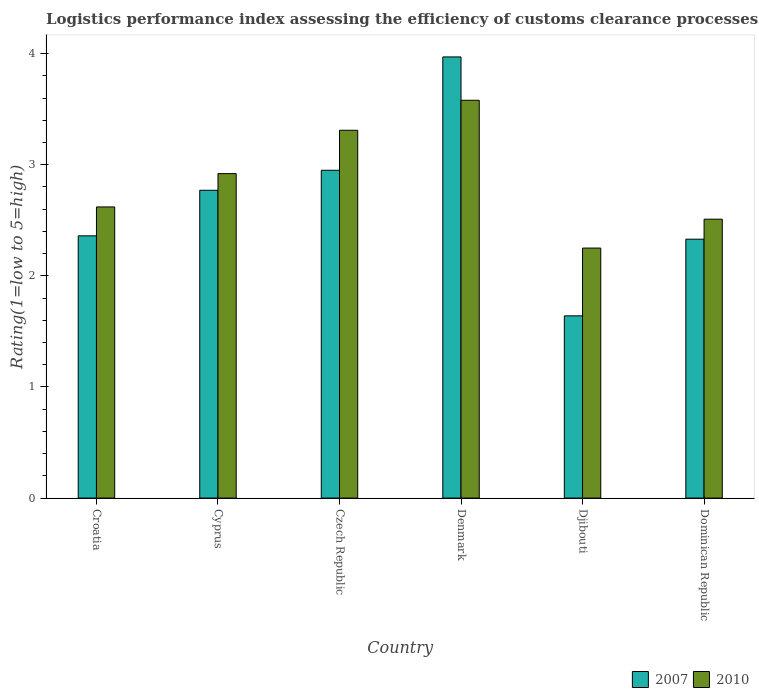Are the number of bars on each tick of the X-axis equal?
Your response must be concise. Yes. How many bars are there on the 6th tick from the left?
Keep it short and to the point. 2. How many bars are there on the 1st tick from the right?
Your answer should be very brief. 2. What is the label of the 1st group of bars from the left?
Offer a very short reply. Croatia. In how many cases, is the number of bars for a given country not equal to the number of legend labels?
Keep it short and to the point. 0. What is the Logistic performance index in 2007 in Cyprus?
Your answer should be very brief. 2.77. Across all countries, what is the maximum Logistic performance index in 2010?
Provide a short and direct response. 3.58. Across all countries, what is the minimum Logistic performance index in 2010?
Provide a succinct answer. 2.25. In which country was the Logistic performance index in 2007 maximum?
Your response must be concise. Denmark. In which country was the Logistic performance index in 2010 minimum?
Your answer should be compact. Djibouti. What is the total Logistic performance index in 2010 in the graph?
Make the answer very short. 17.19. What is the difference between the Logistic performance index in 2010 in Cyprus and that in Dominican Republic?
Offer a terse response. 0.41. What is the difference between the Logistic performance index in 2010 in Djibouti and the Logistic performance index in 2007 in Cyprus?
Your response must be concise. -0.52. What is the average Logistic performance index in 2010 per country?
Ensure brevity in your answer.  2.86. What is the difference between the Logistic performance index of/in 2010 and Logistic performance index of/in 2007 in Djibouti?
Offer a terse response. 0.61. In how many countries, is the Logistic performance index in 2010 greater than 0.2?
Ensure brevity in your answer.  6. What is the ratio of the Logistic performance index in 2010 in Cyprus to that in Dominican Republic?
Offer a terse response. 1.16. Is the Logistic performance index in 2010 in Cyprus less than that in Czech Republic?
Make the answer very short. Yes. What is the difference between the highest and the second highest Logistic performance index in 2007?
Give a very brief answer. -0.18. What is the difference between the highest and the lowest Logistic performance index in 2010?
Keep it short and to the point. 1.33. In how many countries, is the Logistic performance index in 2007 greater than the average Logistic performance index in 2007 taken over all countries?
Your answer should be very brief. 3. Is the sum of the Logistic performance index in 2007 in Croatia and Czech Republic greater than the maximum Logistic performance index in 2010 across all countries?
Offer a very short reply. Yes. What does the 1st bar from the right in Djibouti represents?
Offer a terse response. 2010. What is the difference between two consecutive major ticks on the Y-axis?
Provide a succinct answer. 1. Are the values on the major ticks of Y-axis written in scientific E-notation?
Your response must be concise. No. Does the graph contain any zero values?
Your answer should be compact. No. Does the graph contain grids?
Provide a succinct answer. No. Where does the legend appear in the graph?
Give a very brief answer. Bottom right. How many legend labels are there?
Your response must be concise. 2. How are the legend labels stacked?
Offer a very short reply. Horizontal. What is the title of the graph?
Make the answer very short. Logistics performance index assessing the efficiency of customs clearance processes. Does "1985" appear as one of the legend labels in the graph?
Provide a short and direct response. No. What is the label or title of the X-axis?
Make the answer very short. Country. What is the label or title of the Y-axis?
Make the answer very short. Rating(1=low to 5=high). What is the Rating(1=low to 5=high) of 2007 in Croatia?
Ensure brevity in your answer.  2.36. What is the Rating(1=low to 5=high) in 2010 in Croatia?
Make the answer very short. 2.62. What is the Rating(1=low to 5=high) in 2007 in Cyprus?
Your answer should be compact. 2.77. What is the Rating(1=low to 5=high) of 2010 in Cyprus?
Offer a very short reply. 2.92. What is the Rating(1=low to 5=high) in 2007 in Czech Republic?
Make the answer very short. 2.95. What is the Rating(1=low to 5=high) in 2010 in Czech Republic?
Offer a very short reply. 3.31. What is the Rating(1=low to 5=high) of 2007 in Denmark?
Provide a succinct answer. 3.97. What is the Rating(1=low to 5=high) in 2010 in Denmark?
Your answer should be very brief. 3.58. What is the Rating(1=low to 5=high) of 2007 in Djibouti?
Give a very brief answer. 1.64. What is the Rating(1=low to 5=high) of 2010 in Djibouti?
Offer a very short reply. 2.25. What is the Rating(1=low to 5=high) of 2007 in Dominican Republic?
Provide a short and direct response. 2.33. What is the Rating(1=low to 5=high) of 2010 in Dominican Republic?
Offer a very short reply. 2.51. Across all countries, what is the maximum Rating(1=low to 5=high) in 2007?
Ensure brevity in your answer.  3.97. Across all countries, what is the maximum Rating(1=low to 5=high) in 2010?
Your answer should be compact. 3.58. Across all countries, what is the minimum Rating(1=low to 5=high) of 2007?
Your answer should be compact. 1.64. Across all countries, what is the minimum Rating(1=low to 5=high) in 2010?
Make the answer very short. 2.25. What is the total Rating(1=low to 5=high) in 2007 in the graph?
Keep it short and to the point. 16.02. What is the total Rating(1=low to 5=high) in 2010 in the graph?
Offer a very short reply. 17.19. What is the difference between the Rating(1=low to 5=high) in 2007 in Croatia and that in Cyprus?
Your answer should be compact. -0.41. What is the difference between the Rating(1=low to 5=high) in 2010 in Croatia and that in Cyprus?
Your answer should be compact. -0.3. What is the difference between the Rating(1=low to 5=high) of 2007 in Croatia and that in Czech Republic?
Give a very brief answer. -0.59. What is the difference between the Rating(1=low to 5=high) of 2010 in Croatia and that in Czech Republic?
Offer a very short reply. -0.69. What is the difference between the Rating(1=low to 5=high) in 2007 in Croatia and that in Denmark?
Keep it short and to the point. -1.61. What is the difference between the Rating(1=low to 5=high) in 2010 in Croatia and that in Denmark?
Provide a short and direct response. -0.96. What is the difference between the Rating(1=low to 5=high) of 2007 in Croatia and that in Djibouti?
Your response must be concise. 0.72. What is the difference between the Rating(1=low to 5=high) of 2010 in Croatia and that in Djibouti?
Ensure brevity in your answer.  0.37. What is the difference between the Rating(1=low to 5=high) in 2010 in Croatia and that in Dominican Republic?
Keep it short and to the point. 0.11. What is the difference between the Rating(1=low to 5=high) of 2007 in Cyprus and that in Czech Republic?
Your answer should be compact. -0.18. What is the difference between the Rating(1=low to 5=high) of 2010 in Cyprus and that in Czech Republic?
Provide a short and direct response. -0.39. What is the difference between the Rating(1=low to 5=high) of 2007 in Cyprus and that in Denmark?
Give a very brief answer. -1.2. What is the difference between the Rating(1=low to 5=high) in 2010 in Cyprus and that in Denmark?
Offer a very short reply. -0.66. What is the difference between the Rating(1=low to 5=high) of 2007 in Cyprus and that in Djibouti?
Offer a very short reply. 1.13. What is the difference between the Rating(1=low to 5=high) in 2010 in Cyprus and that in Djibouti?
Provide a succinct answer. 0.67. What is the difference between the Rating(1=low to 5=high) in 2007 in Cyprus and that in Dominican Republic?
Keep it short and to the point. 0.44. What is the difference between the Rating(1=low to 5=high) of 2010 in Cyprus and that in Dominican Republic?
Provide a short and direct response. 0.41. What is the difference between the Rating(1=low to 5=high) in 2007 in Czech Republic and that in Denmark?
Your response must be concise. -1.02. What is the difference between the Rating(1=low to 5=high) of 2010 in Czech Republic and that in Denmark?
Your answer should be very brief. -0.27. What is the difference between the Rating(1=low to 5=high) of 2007 in Czech Republic and that in Djibouti?
Your response must be concise. 1.31. What is the difference between the Rating(1=low to 5=high) in 2010 in Czech Republic and that in Djibouti?
Offer a very short reply. 1.06. What is the difference between the Rating(1=low to 5=high) of 2007 in Czech Republic and that in Dominican Republic?
Your answer should be compact. 0.62. What is the difference between the Rating(1=low to 5=high) in 2007 in Denmark and that in Djibouti?
Keep it short and to the point. 2.33. What is the difference between the Rating(1=low to 5=high) of 2010 in Denmark and that in Djibouti?
Offer a very short reply. 1.33. What is the difference between the Rating(1=low to 5=high) of 2007 in Denmark and that in Dominican Republic?
Provide a short and direct response. 1.64. What is the difference between the Rating(1=low to 5=high) of 2010 in Denmark and that in Dominican Republic?
Provide a succinct answer. 1.07. What is the difference between the Rating(1=low to 5=high) of 2007 in Djibouti and that in Dominican Republic?
Your response must be concise. -0.69. What is the difference between the Rating(1=low to 5=high) in 2010 in Djibouti and that in Dominican Republic?
Your response must be concise. -0.26. What is the difference between the Rating(1=low to 5=high) in 2007 in Croatia and the Rating(1=low to 5=high) in 2010 in Cyprus?
Ensure brevity in your answer.  -0.56. What is the difference between the Rating(1=low to 5=high) in 2007 in Croatia and the Rating(1=low to 5=high) in 2010 in Czech Republic?
Give a very brief answer. -0.95. What is the difference between the Rating(1=low to 5=high) of 2007 in Croatia and the Rating(1=low to 5=high) of 2010 in Denmark?
Your answer should be compact. -1.22. What is the difference between the Rating(1=low to 5=high) in 2007 in Croatia and the Rating(1=low to 5=high) in 2010 in Djibouti?
Offer a terse response. 0.11. What is the difference between the Rating(1=low to 5=high) in 2007 in Cyprus and the Rating(1=low to 5=high) in 2010 in Czech Republic?
Your response must be concise. -0.54. What is the difference between the Rating(1=low to 5=high) in 2007 in Cyprus and the Rating(1=low to 5=high) in 2010 in Denmark?
Provide a short and direct response. -0.81. What is the difference between the Rating(1=low to 5=high) of 2007 in Cyprus and the Rating(1=low to 5=high) of 2010 in Djibouti?
Provide a short and direct response. 0.52. What is the difference between the Rating(1=low to 5=high) in 2007 in Cyprus and the Rating(1=low to 5=high) in 2010 in Dominican Republic?
Offer a very short reply. 0.26. What is the difference between the Rating(1=low to 5=high) of 2007 in Czech Republic and the Rating(1=low to 5=high) of 2010 in Denmark?
Provide a succinct answer. -0.63. What is the difference between the Rating(1=low to 5=high) in 2007 in Czech Republic and the Rating(1=low to 5=high) in 2010 in Djibouti?
Ensure brevity in your answer.  0.7. What is the difference between the Rating(1=low to 5=high) of 2007 in Czech Republic and the Rating(1=low to 5=high) of 2010 in Dominican Republic?
Give a very brief answer. 0.44. What is the difference between the Rating(1=low to 5=high) of 2007 in Denmark and the Rating(1=low to 5=high) of 2010 in Djibouti?
Give a very brief answer. 1.72. What is the difference between the Rating(1=low to 5=high) of 2007 in Denmark and the Rating(1=low to 5=high) of 2010 in Dominican Republic?
Keep it short and to the point. 1.46. What is the difference between the Rating(1=low to 5=high) of 2007 in Djibouti and the Rating(1=low to 5=high) of 2010 in Dominican Republic?
Ensure brevity in your answer.  -0.87. What is the average Rating(1=low to 5=high) of 2007 per country?
Ensure brevity in your answer.  2.67. What is the average Rating(1=low to 5=high) in 2010 per country?
Offer a very short reply. 2.87. What is the difference between the Rating(1=low to 5=high) of 2007 and Rating(1=low to 5=high) of 2010 in Croatia?
Offer a very short reply. -0.26. What is the difference between the Rating(1=low to 5=high) in 2007 and Rating(1=low to 5=high) in 2010 in Czech Republic?
Your answer should be very brief. -0.36. What is the difference between the Rating(1=low to 5=high) of 2007 and Rating(1=low to 5=high) of 2010 in Denmark?
Offer a very short reply. 0.39. What is the difference between the Rating(1=low to 5=high) of 2007 and Rating(1=low to 5=high) of 2010 in Djibouti?
Keep it short and to the point. -0.61. What is the difference between the Rating(1=low to 5=high) in 2007 and Rating(1=low to 5=high) in 2010 in Dominican Republic?
Offer a very short reply. -0.18. What is the ratio of the Rating(1=low to 5=high) of 2007 in Croatia to that in Cyprus?
Offer a very short reply. 0.85. What is the ratio of the Rating(1=low to 5=high) in 2010 in Croatia to that in Cyprus?
Provide a short and direct response. 0.9. What is the ratio of the Rating(1=low to 5=high) in 2007 in Croatia to that in Czech Republic?
Ensure brevity in your answer.  0.8. What is the ratio of the Rating(1=low to 5=high) of 2010 in Croatia to that in Czech Republic?
Provide a short and direct response. 0.79. What is the ratio of the Rating(1=low to 5=high) of 2007 in Croatia to that in Denmark?
Offer a very short reply. 0.59. What is the ratio of the Rating(1=low to 5=high) of 2010 in Croatia to that in Denmark?
Provide a succinct answer. 0.73. What is the ratio of the Rating(1=low to 5=high) of 2007 in Croatia to that in Djibouti?
Offer a very short reply. 1.44. What is the ratio of the Rating(1=low to 5=high) of 2010 in Croatia to that in Djibouti?
Give a very brief answer. 1.16. What is the ratio of the Rating(1=low to 5=high) of 2007 in Croatia to that in Dominican Republic?
Give a very brief answer. 1.01. What is the ratio of the Rating(1=low to 5=high) in 2010 in Croatia to that in Dominican Republic?
Give a very brief answer. 1.04. What is the ratio of the Rating(1=low to 5=high) of 2007 in Cyprus to that in Czech Republic?
Your answer should be very brief. 0.94. What is the ratio of the Rating(1=low to 5=high) in 2010 in Cyprus to that in Czech Republic?
Your answer should be very brief. 0.88. What is the ratio of the Rating(1=low to 5=high) in 2007 in Cyprus to that in Denmark?
Give a very brief answer. 0.7. What is the ratio of the Rating(1=low to 5=high) of 2010 in Cyprus to that in Denmark?
Offer a very short reply. 0.82. What is the ratio of the Rating(1=low to 5=high) of 2007 in Cyprus to that in Djibouti?
Offer a very short reply. 1.69. What is the ratio of the Rating(1=low to 5=high) of 2010 in Cyprus to that in Djibouti?
Make the answer very short. 1.3. What is the ratio of the Rating(1=low to 5=high) of 2007 in Cyprus to that in Dominican Republic?
Make the answer very short. 1.19. What is the ratio of the Rating(1=low to 5=high) of 2010 in Cyprus to that in Dominican Republic?
Provide a short and direct response. 1.16. What is the ratio of the Rating(1=low to 5=high) in 2007 in Czech Republic to that in Denmark?
Provide a succinct answer. 0.74. What is the ratio of the Rating(1=low to 5=high) of 2010 in Czech Republic to that in Denmark?
Keep it short and to the point. 0.92. What is the ratio of the Rating(1=low to 5=high) of 2007 in Czech Republic to that in Djibouti?
Offer a very short reply. 1.8. What is the ratio of the Rating(1=low to 5=high) in 2010 in Czech Republic to that in Djibouti?
Your response must be concise. 1.47. What is the ratio of the Rating(1=low to 5=high) of 2007 in Czech Republic to that in Dominican Republic?
Make the answer very short. 1.27. What is the ratio of the Rating(1=low to 5=high) in 2010 in Czech Republic to that in Dominican Republic?
Your answer should be very brief. 1.32. What is the ratio of the Rating(1=low to 5=high) in 2007 in Denmark to that in Djibouti?
Your answer should be compact. 2.42. What is the ratio of the Rating(1=low to 5=high) of 2010 in Denmark to that in Djibouti?
Provide a short and direct response. 1.59. What is the ratio of the Rating(1=low to 5=high) of 2007 in Denmark to that in Dominican Republic?
Ensure brevity in your answer.  1.7. What is the ratio of the Rating(1=low to 5=high) in 2010 in Denmark to that in Dominican Republic?
Make the answer very short. 1.43. What is the ratio of the Rating(1=low to 5=high) in 2007 in Djibouti to that in Dominican Republic?
Provide a succinct answer. 0.7. What is the ratio of the Rating(1=low to 5=high) in 2010 in Djibouti to that in Dominican Republic?
Make the answer very short. 0.9. What is the difference between the highest and the second highest Rating(1=low to 5=high) of 2007?
Ensure brevity in your answer.  1.02. What is the difference between the highest and the second highest Rating(1=low to 5=high) in 2010?
Offer a terse response. 0.27. What is the difference between the highest and the lowest Rating(1=low to 5=high) of 2007?
Offer a terse response. 2.33. What is the difference between the highest and the lowest Rating(1=low to 5=high) of 2010?
Offer a terse response. 1.33. 